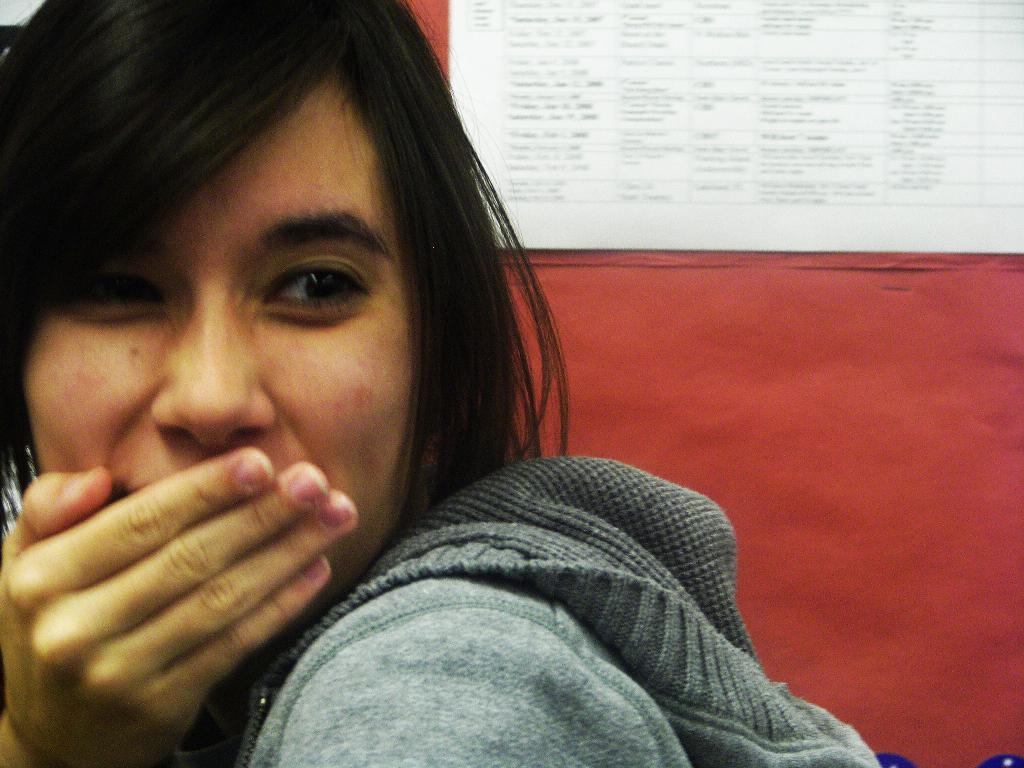What is the main subject in the foreground of the image? There is a person in the foreground of the image. On which side of the image is the person located? The person is on the left side. What can be seen in the background of the image? There is a poster in the background of the image. What is the color of the surface on which the poster is placed? The poster is on a red surface. What type of fowl can be seen learning in the image? There is no fowl present in the image, and no learning activity is depicted. How hot is the person in the image? The temperature of the person in the image cannot be determined from the image itself. 